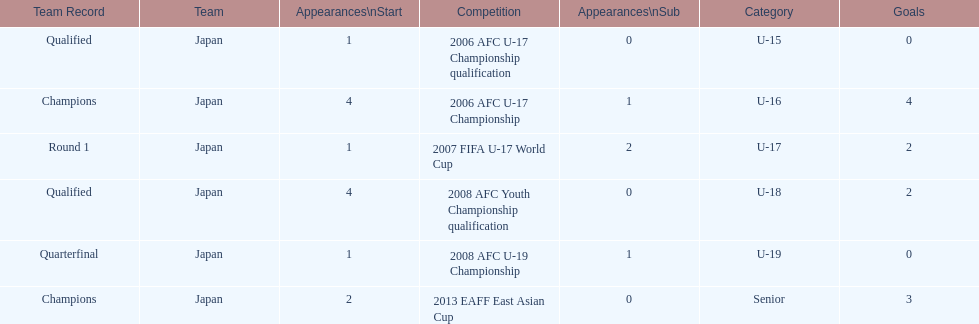Can you parse all the data within this table? {'header': ['Team Record', 'Team', 'Appearances\\nStart', 'Competition', 'Appearances\\nSub', 'Category', 'Goals'], 'rows': [['Qualified', 'Japan', '1', '2006 AFC U-17 Championship qualification', '0', 'U-15', '0'], ['Champions', 'Japan', '4', '2006 AFC U-17 Championship', '1', 'U-16', '4'], ['Round 1', 'Japan', '1', '2007 FIFA U-17 World Cup', '2', 'U-17', '2'], ['Qualified', 'Japan', '4', '2008 AFC Youth Championship qualification', '0', 'U-18', '2'], ['Quarterfinal', 'Japan', '1', '2008 AFC U-19 Championship', '1', 'U-19', '0'], ['Champions', 'Japan', '2', '2013 EAFF East Asian Cup', '0', 'Senior', '3']]} Where did japan only score four goals? 2006 AFC U-17 Championship. 